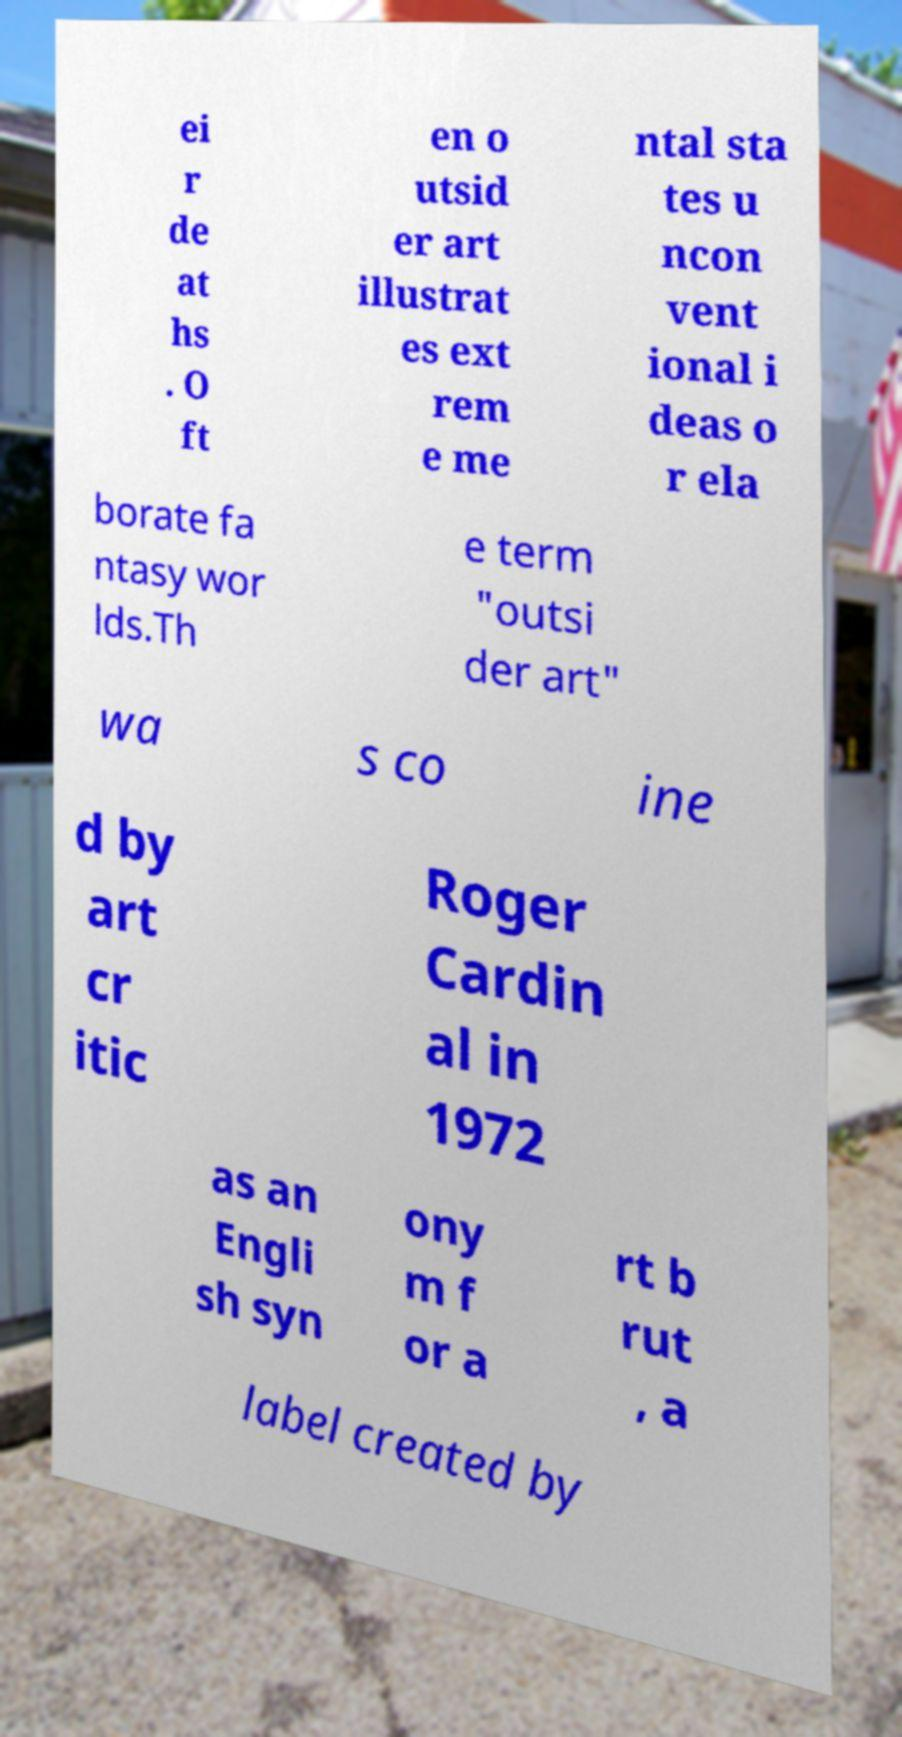Can you read and provide the text displayed in the image?This photo seems to have some interesting text. Can you extract and type it out for me? ei r de at hs . O ft en o utsid er art illustrat es ext rem e me ntal sta tes u ncon vent ional i deas o r ela borate fa ntasy wor lds.Th e term "outsi der art" wa s co ine d by art cr itic Roger Cardin al in 1972 as an Engli sh syn ony m f or a rt b rut , a label created by 